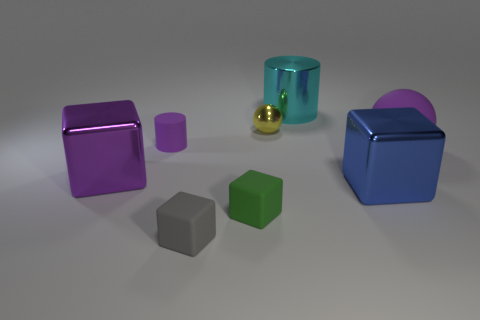There is a cylinder that is the same size as the rubber ball; what color is it? The cylinder that matches the size of the rubber ball is a translucent turquoise, offering a modern aesthetic alongside the other geometric shapes. 